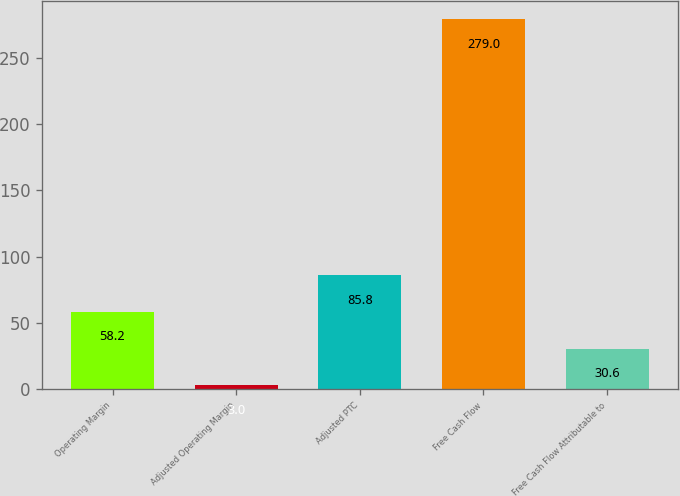Convert chart. <chart><loc_0><loc_0><loc_500><loc_500><bar_chart><fcel>Operating Margin<fcel>Adjusted Operating Margin<fcel>Adjusted PTC<fcel>Free Cash Flow<fcel>Free Cash Flow Attributable to<nl><fcel>58.2<fcel>3<fcel>85.8<fcel>279<fcel>30.6<nl></chart> 